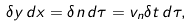Convert formula to latex. <formula><loc_0><loc_0><loc_500><loc_500>\delta y \, d x = \delta n \, d \tau = v _ { n } \delta t \, d \tau ,</formula> 